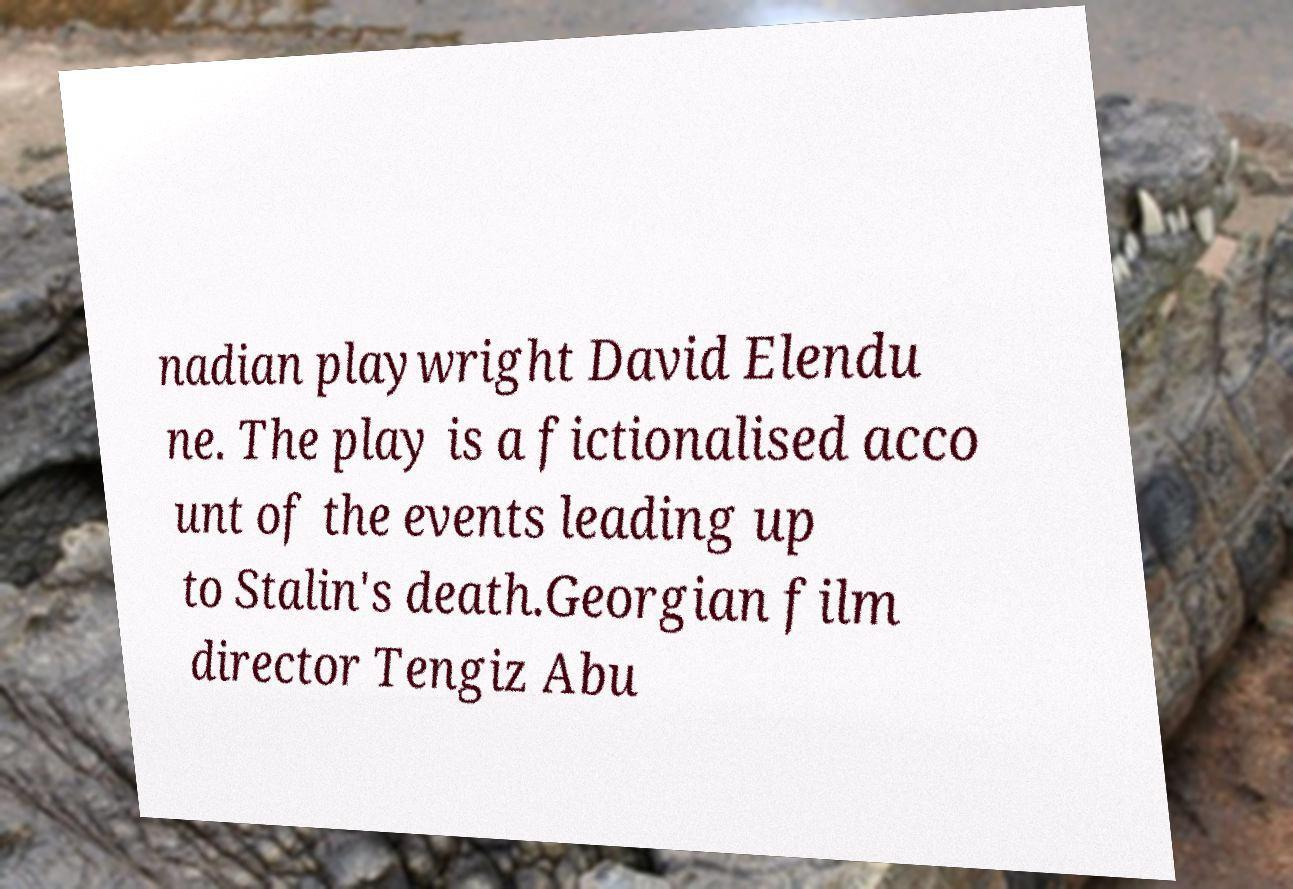Can you accurately transcribe the text from the provided image for me? nadian playwright David Elendu ne. The play is a fictionalised acco unt of the events leading up to Stalin's death.Georgian film director Tengiz Abu 